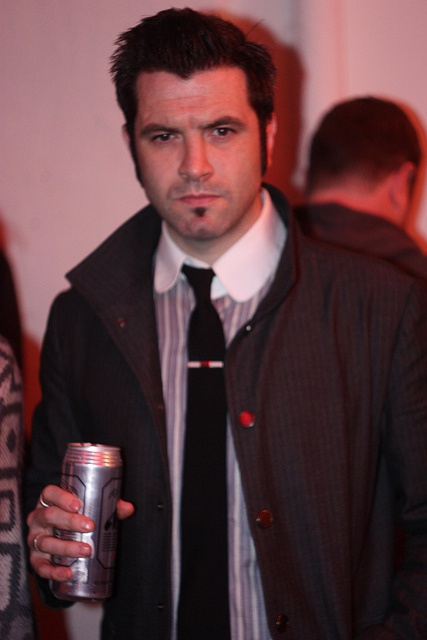Describe the objects in this image and their specific colors. I can see people in black, gray, brown, and salmon tones, people in gray, black, maroon, and brown tones, and tie in gray and black tones in this image. 